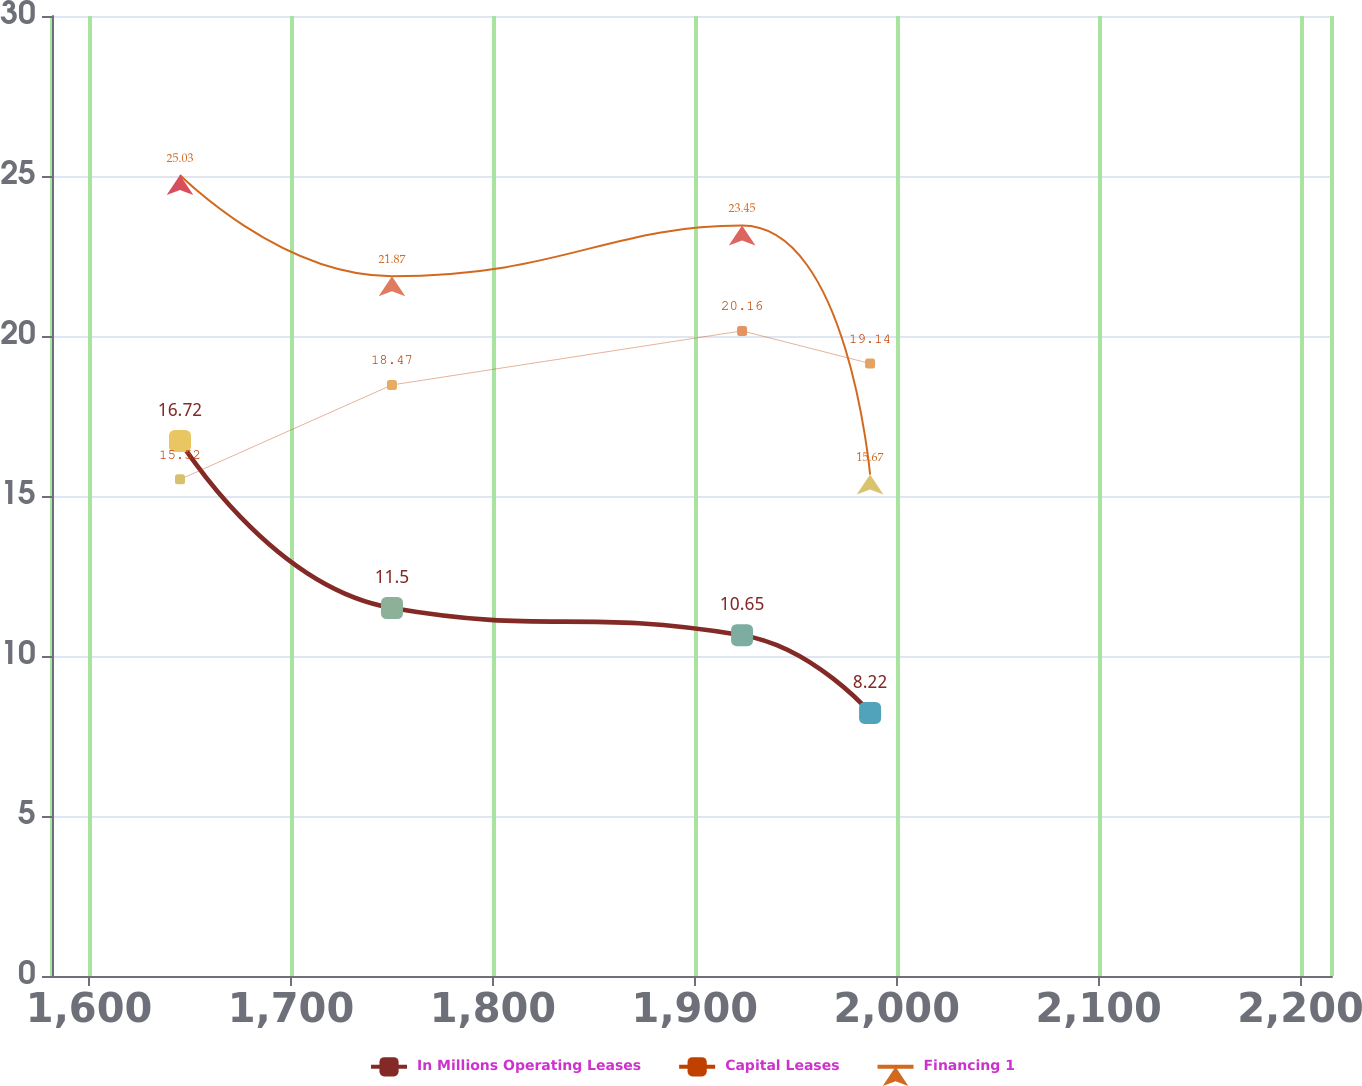Convert chart to OTSL. <chart><loc_0><loc_0><loc_500><loc_500><line_chart><ecel><fcel>In Millions Operating Leases<fcel>Capital Leases<fcel>Financing 1<nl><fcel>1645.03<fcel>16.72<fcel>15.52<fcel>25.03<nl><fcel>1750.01<fcel>11.5<fcel>18.47<fcel>21.87<nl><fcel>1923.41<fcel>10.65<fcel>20.16<fcel>23.45<nl><fcel>1986.8<fcel>8.22<fcel>19.14<fcel>15.67<nl><fcel>2278.97<fcel>12.35<fcel>13.5<fcel>8.78<nl></chart> 